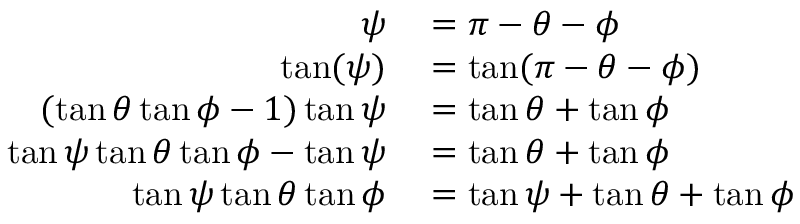Convert formula to latex. <formula><loc_0><loc_0><loc_500><loc_500>\begin{array} { r l } { \psi } & = \pi - \theta - \phi } \\ { \tan ( \psi ) } & = \tan ( \pi - \theta - \phi ) } \\ { ( \tan \theta \tan \phi - 1 ) \tan \psi } & = \tan \theta + \tan \phi } \\ { \tan \psi \tan \theta \tan \phi - \tan \psi } & = \tan \theta + \tan \phi } \\ { \tan \psi \tan \theta \tan \phi } & = \tan \psi + \tan \theta + \tan \phi } \end{array}</formula> 